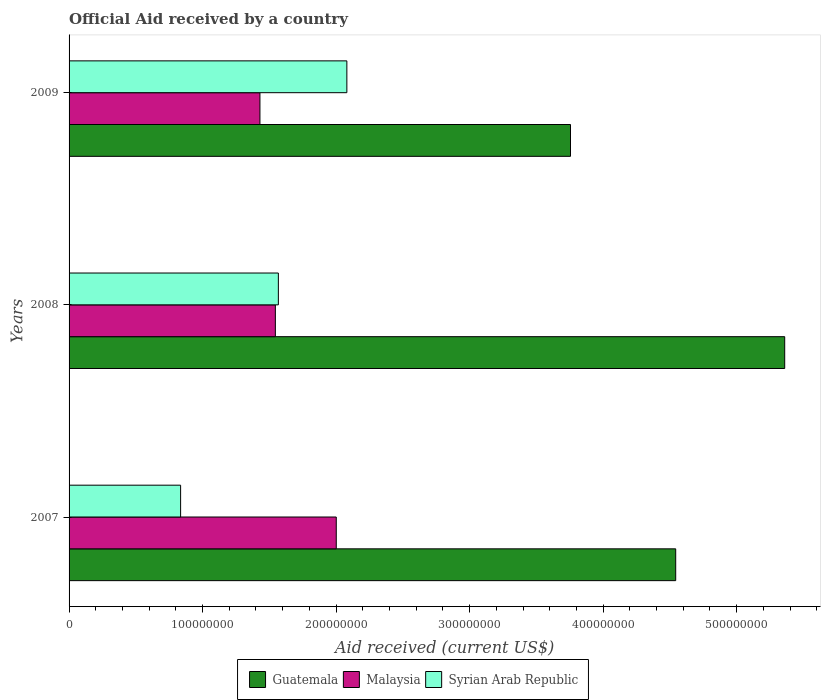How many different coloured bars are there?
Your answer should be very brief. 3. How many bars are there on the 3rd tick from the top?
Ensure brevity in your answer.  3. How many bars are there on the 1st tick from the bottom?
Offer a very short reply. 3. What is the label of the 3rd group of bars from the top?
Provide a short and direct response. 2007. What is the net official aid received in Guatemala in 2008?
Give a very brief answer. 5.36e+08. Across all years, what is the maximum net official aid received in Malaysia?
Keep it short and to the point. 2.00e+08. Across all years, what is the minimum net official aid received in Guatemala?
Offer a terse response. 3.76e+08. What is the total net official aid received in Malaysia in the graph?
Offer a very short reply. 4.98e+08. What is the difference between the net official aid received in Guatemala in 2007 and that in 2008?
Make the answer very short. -8.16e+07. What is the difference between the net official aid received in Malaysia in 2008 and the net official aid received in Syrian Arab Republic in 2007?
Provide a succinct answer. 7.10e+07. What is the average net official aid received in Guatemala per year?
Give a very brief answer. 4.55e+08. In the year 2007, what is the difference between the net official aid received in Syrian Arab Republic and net official aid received in Guatemala?
Offer a very short reply. -3.71e+08. What is the ratio of the net official aid received in Malaysia in 2007 to that in 2009?
Your response must be concise. 1.4. Is the net official aid received in Guatemala in 2007 less than that in 2008?
Provide a succinct answer. Yes. Is the difference between the net official aid received in Syrian Arab Republic in 2008 and 2009 greater than the difference between the net official aid received in Guatemala in 2008 and 2009?
Provide a succinct answer. No. What is the difference between the highest and the second highest net official aid received in Malaysia?
Your answer should be compact. 4.56e+07. What is the difference between the highest and the lowest net official aid received in Syrian Arab Republic?
Provide a short and direct response. 1.25e+08. In how many years, is the net official aid received in Guatemala greater than the average net official aid received in Guatemala taken over all years?
Ensure brevity in your answer.  1. Is the sum of the net official aid received in Malaysia in 2007 and 2008 greater than the maximum net official aid received in Guatemala across all years?
Make the answer very short. No. What does the 2nd bar from the top in 2007 represents?
Your response must be concise. Malaysia. What does the 1st bar from the bottom in 2008 represents?
Your response must be concise. Guatemala. How many bars are there?
Your answer should be very brief. 9. How many years are there in the graph?
Give a very brief answer. 3. Are the values on the major ticks of X-axis written in scientific E-notation?
Your response must be concise. No. Does the graph contain any zero values?
Provide a short and direct response. No. What is the title of the graph?
Your response must be concise. Official Aid received by a country. Does "Ukraine" appear as one of the legend labels in the graph?
Give a very brief answer. No. What is the label or title of the X-axis?
Offer a very short reply. Aid received (current US$). What is the label or title of the Y-axis?
Provide a short and direct response. Years. What is the Aid received (current US$) in Guatemala in 2007?
Give a very brief answer. 4.54e+08. What is the Aid received (current US$) of Malaysia in 2007?
Keep it short and to the point. 2.00e+08. What is the Aid received (current US$) in Syrian Arab Republic in 2007?
Offer a very short reply. 8.35e+07. What is the Aid received (current US$) in Guatemala in 2008?
Provide a succinct answer. 5.36e+08. What is the Aid received (current US$) in Malaysia in 2008?
Provide a short and direct response. 1.55e+08. What is the Aid received (current US$) in Syrian Arab Republic in 2008?
Give a very brief answer. 1.57e+08. What is the Aid received (current US$) in Guatemala in 2009?
Provide a short and direct response. 3.76e+08. What is the Aid received (current US$) in Malaysia in 2009?
Keep it short and to the point. 1.43e+08. What is the Aid received (current US$) of Syrian Arab Republic in 2009?
Give a very brief answer. 2.08e+08. Across all years, what is the maximum Aid received (current US$) in Guatemala?
Offer a very short reply. 5.36e+08. Across all years, what is the maximum Aid received (current US$) of Malaysia?
Give a very brief answer. 2.00e+08. Across all years, what is the maximum Aid received (current US$) in Syrian Arab Republic?
Your answer should be very brief. 2.08e+08. Across all years, what is the minimum Aid received (current US$) of Guatemala?
Your response must be concise. 3.76e+08. Across all years, what is the minimum Aid received (current US$) in Malaysia?
Offer a very short reply. 1.43e+08. Across all years, what is the minimum Aid received (current US$) of Syrian Arab Republic?
Provide a succinct answer. 8.35e+07. What is the total Aid received (current US$) of Guatemala in the graph?
Your response must be concise. 1.37e+09. What is the total Aid received (current US$) in Malaysia in the graph?
Offer a terse response. 4.98e+08. What is the total Aid received (current US$) in Syrian Arab Republic in the graph?
Ensure brevity in your answer.  4.48e+08. What is the difference between the Aid received (current US$) in Guatemala in 2007 and that in 2008?
Offer a terse response. -8.16e+07. What is the difference between the Aid received (current US$) in Malaysia in 2007 and that in 2008?
Your response must be concise. 4.56e+07. What is the difference between the Aid received (current US$) of Syrian Arab Republic in 2007 and that in 2008?
Provide a succinct answer. -7.32e+07. What is the difference between the Aid received (current US$) in Guatemala in 2007 and that in 2009?
Offer a terse response. 7.88e+07. What is the difference between the Aid received (current US$) in Malaysia in 2007 and that in 2009?
Ensure brevity in your answer.  5.72e+07. What is the difference between the Aid received (current US$) in Syrian Arab Republic in 2007 and that in 2009?
Make the answer very short. -1.25e+08. What is the difference between the Aid received (current US$) of Guatemala in 2008 and that in 2009?
Your answer should be very brief. 1.60e+08. What is the difference between the Aid received (current US$) of Malaysia in 2008 and that in 2009?
Provide a short and direct response. 1.16e+07. What is the difference between the Aid received (current US$) in Syrian Arab Republic in 2008 and that in 2009?
Give a very brief answer. -5.13e+07. What is the difference between the Aid received (current US$) of Guatemala in 2007 and the Aid received (current US$) of Malaysia in 2008?
Provide a short and direct response. 3.00e+08. What is the difference between the Aid received (current US$) in Guatemala in 2007 and the Aid received (current US$) in Syrian Arab Republic in 2008?
Keep it short and to the point. 2.98e+08. What is the difference between the Aid received (current US$) of Malaysia in 2007 and the Aid received (current US$) of Syrian Arab Republic in 2008?
Provide a succinct answer. 4.34e+07. What is the difference between the Aid received (current US$) in Guatemala in 2007 and the Aid received (current US$) in Malaysia in 2009?
Offer a terse response. 3.11e+08. What is the difference between the Aid received (current US$) of Guatemala in 2007 and the Aid received (current US$) of Syrian Arab Republic in 2009?
Your response must be concise. 2.46e+08. What is the difference between the Aid received (current US$) in Malaysia in 2007 and the Aid received (current US$) in Syrian Arab Republic in 2009?
Provide a succinct answer. -7.94e+06. What is the difference between the Aid received (current US$) of Guatemala in 2008 and the Aid received (current US$) of Malaysia in 2009?
Keep it short and to the point. 3.93e+08. What is the difference between the Aid received (current US$) of Guatemala in 2008 and the Aid received (current US$) of Syrian Arab Republic in 2009?
Your answer should be compact. 3.28e+08. What is the difference between the Aid received (current US$) in Malaysia in 2008 and the Aid received (current US$) in Syrian Arab Republic in 2009?
Provide a short and direct response. -5.36e+07. What is the average Aid received (current US$) of Guatemala per year?
Offer a terse response. 4.55e+08. What is the average Aid received (current US$) in Malaysia per year?
Your answer should be compact. 1.66e+08. What is the average Aid received (current US$) in Syrian Arab Republic per year?
Provide a short and direct response. 1.49e+08. In the year 2007, what is the difference between the Aid received (current US$) of Guatemala and Aid received (current US$) of Malaysia?
Make the answer very short. 2.54e+08. In the year 2007, what is the difference between the Aid received (current US$) in Guatemala and Aid received (current US$) in Syrian Arab Republic?
Keep it short and to the point. 3.71e+08. In the year 2007, what is the difference between the Aid received (current US$) in Malaysia and Aid received (current US$) in Syrian Arab Republic?
Your answer should be compact. 1.17e+08. In the year 2008, what is the difference between the Aid received (current US$) in Guatemala and Aid received (current US$) in Malaysia?
Your response must be concise. 3.82e+08. In the year 2008, what is the difference between the Aid received (current US$) of Guatemala and Aid received (current US$) of Syrian Arab Republic?
Offer a very short reply. 3.79e+08. In the year 2008, what is the difference between the Aid received (current US$) in Malaysia and Aid received (current US$) in Syrian Arab Republic?
Give a very brief answer. -2.25e+06. In the year 2009, what is the difference between the Aid received (current US$) in Guatemala and Aid received (current US$) in Malaysia?
Give a very brief answer. 2.33e+08. In the year 2009, what is the difference between the Aid received (current US$) of Guatemala and Aid received (current US$) of Syrian Arab Republic?
Make the answer very short. 1.68e+08. In the year 2009, what is the difference between the Aid received (current US$) of Malaysia and Aid received (current US$) of Syrian Arab Republic?
Provide a short and direct response. -6.51e+07. What is the ratio of the Aid received (current US$) in Guatemala in 2007 to that in 2008?
Your response must be concise. 0.85. What is the ratio of the Aid received (current US$) in Malaysia in 2007 to that in 2008?
Ensure brevity in your answer.  1.3. What is the ratio of the Aid received (current US$) of Syrian Arab Republic in 2007 to that in 2008?
Make the answer very short. 0.53. What is the ratio of the Aid received (current US$) of Guatemala in 2007 to that in 2009?
Your answer should be very brief. 1.21. What is the ratio of the Aid received (current US$) in Malaysia in 2007 to that in 2009?
Ensure brevity in your answer.  1.4. What is the ratio of the Aid received (current US$) of Syrian Arab Republic in 2007 to that in 2009?
Offer a very short reply. 0.4. What is the ratio of the Aid received (current US$) of Guatemala in 2008 to that in 2009?
Provide a succinct answer. 1.43. What is the ratio of the Aid received (current US$) of Malaysia in 2008 to that in 2009?
Give a very brief answer. 1.08. What is the ratio of the Aid received (current US$) of Syrian Arab Republic in 2008 to that in 2009?
Make the answer very short. 0.75. What is the difference between the highest and the second highest Aid received (current US$) of Guatemala?
Give a very brief answer. 8.16e+07. What is the difference between the highest and the second highest Aid received (current US$) in Malaysia?
Your answer should be compact. 4.56e+07. What is the difference between the highest and the second highest Aid received (current US$) in Syrian Arab Republic?
Offer a very short reply. 5.13e+07. What is the difference between the highest and the lowest Aid received (current US$) of Guatemala?
Your answer should be compact. 1.60e+08. What is the difference between the highest and the lowest Aid received (current US$) in Malaysia?
Provide a short and direct response. 5.72e+07. What is the difference between the highest and the lowest Aid received (current US$) in Syrian Arab Republic?
Ensure brevity in your answer.  1.25e+08. 